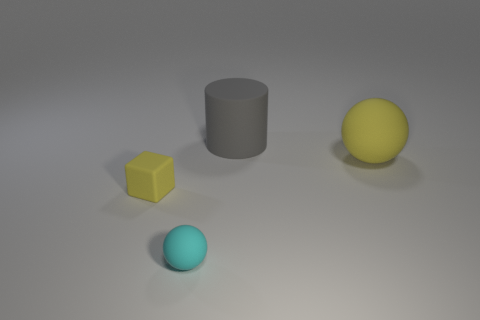There is a tiny object behind the small cyan matte ball; is there a rubber thing in front of it?
Your answer should be very brief. Yes. What number of objects are either matte things that are in front of the large matte sphere or balls behind the tiny yellow rubber block?
Your response must be concise. 3. Is there any other thing that is the same color as the big matte ball?
Offer a terse response. Yes. What is the color of the rubber ball that is on the right side of the gray rubber object that is to the left of the big matte thing in front of the rubber cylinder?
Your answer should be compact. Yellow. What size is the yellow rubber thing that is behind the small object that is to the left of the small ball?
Give a very brief answer. Large. There is a cyan matte ball; does it have the same size as the yellow matte thing that is to the left of the gray matte cylinder?
Your response must be concise. Yes. Are any large metallic cylinders visible?
Offer a terse response. No. What size is the yellow object that is right of the thing that is behind the big yellow rubber sphere behind the tiny rubber block?
Your answer should be very brief. Large. There is a yellow cube; are there any big yellow matte things behind it?
Give a very brief answer. Yes. The yellow sphere that is the same material as the gray cylinder is what size?
Your answer should be compact. Large. 